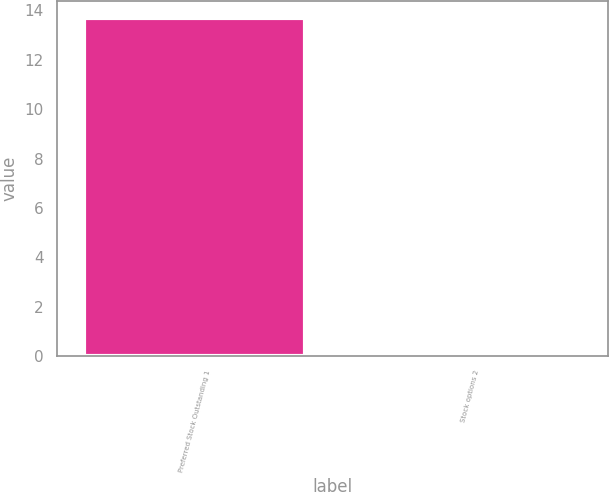<chart> <loc_0><loc_0><loc_500><loc_500><bar_chart><fcel>Preferred Stock Outstanding 1<fcel>Stock options 2<nl><fcel>13.7<fcel>0.1<nl></chart> 